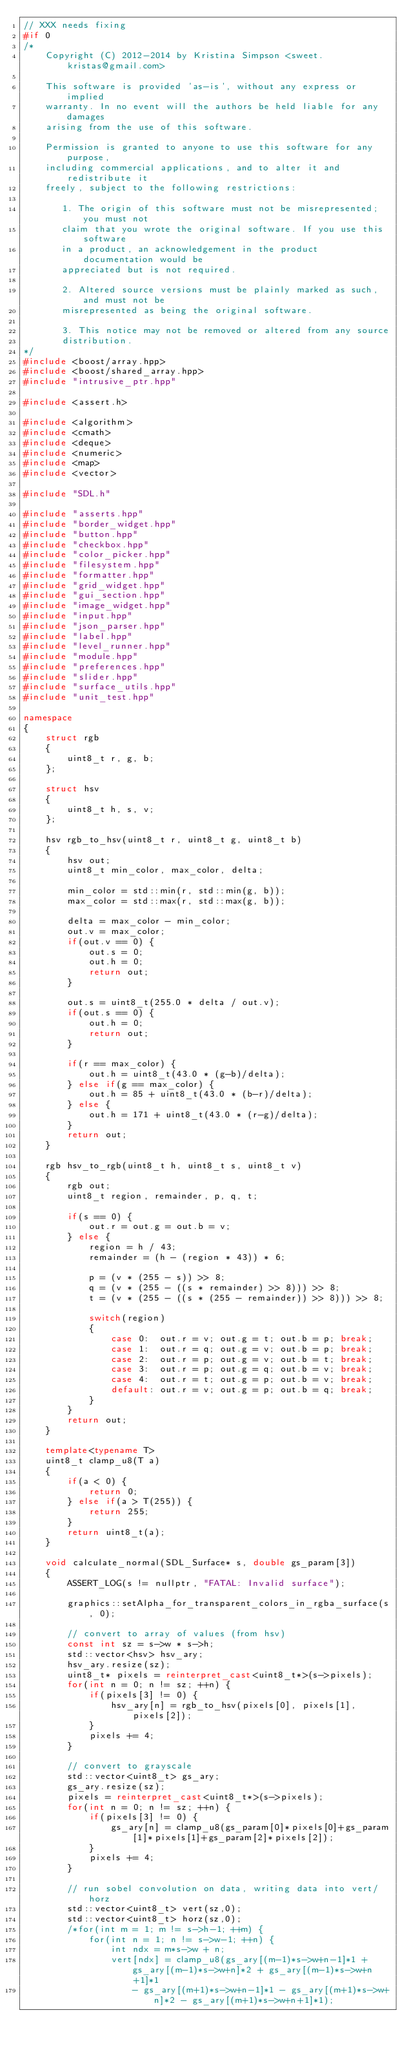Convert code to text. <code><loc_0><loc_0><loc_500><loc_500><_C++_>// XXX needs fixing
#if 0
/*
	Copyright (C) 2012-2014 by Kristina Simpson <sweet.kristas@gmail.com>
	
	This software is provided 'as-is', without any express or implied
	warranty. In no event will the authors be held liable for any damages
	arising from the use of this software.

	Permission is granted to anyone to use this software for any purpose,
	including commercial applications, and to alter it and redistribute it
	freely, subject to the following restrictions:

	   1. The origin of this software must not be misrepresented; you must not
	   claim that you wrote the original software. If you use this software
	   in a product, an acknowledgement in the product documentation would be
	   appreciated but is not required.

	   2. Altered source versions must be plainly marked as such, and must not be
	   misrepresented as being the original software.

	   3. This notice may not be removed or altered from any source
	   distribution.
*/
#include <boost/array.hpp>
#include <boost/shared_array.hpp>
#include "intrusive_ptr.hpp"

#include <assert.h>

#include <algorithm>
#include <cmath>
#include <deque>
#include <numeric>
#include <map>
#include <vector>

#include "SDL.h"

#include "asserts.hpp"
#include "border_widget.hpp"
#include "button.hpp"
#include "checkbox.hpp"
#include "color_picker.hpp"
#include "filesystem.hpp"
#include "formatter.hpp"
#include "grid_widget.hpp"
#include "gui_section.hpp"
#include "image_widget.hpp"
#include "input.hpp"
#include "json_parser.hpp"
#include "label.hpp"
#include "level_runner.hpp"
#include "module.hpp"
#include "preferences.hpp"
#include "slider.hpp"
#include "surface_utils.hpp"
#include "unit_test.hpp"

namespace
{
	struct rgb
	{
		uint8_t r, g, b;
	};

	struct hsv
	{
		uint8_t h, s, v;
	};

	hsv rgb_to_hsv(uint8_t r, uint8_t g, uint8_t b)
	{
		hsv out;
		uint8_t min_color, max_color, delta;

		min_color = std::min(r, std::min(g, b));
		max_color = std::max(r, std::max(g, b));

		delta = max_color - min_color;
		out.v = max_color;
		if(out.v == 0) {
			out.s = 0;
			out.h = 0;
			return out;
		}

		out.s = uint8_t(255.0 * delta / out.v);
		if(out.s == 0) {
			out.h = 0;
			return out;
		}

		if(r == max_color) {
			out.h = uint8_t(43.0 * (g-b)/delta);
		} else if(g == max_color) {
			out.h = 85 + uint8_t(43.0 * (b-r)/delta);
		} else {
			out.h = 171 + uint8_t(43.0 * (r-g)/delta);
		}
		return out;
	}

	rgb hsv_to_rgb(uint8_t h, uint8_t s, uint8_t v)
	{
		rgb out;
		uint8_t region, remainder, p, q, t;

		if(s == 0) {
			out.r = out.g = out.b = v;
		} else {
			region = h / 43;
			remainder = (h - (region * 43)) * 6; 

			p = (v * (255 - s)) >> 8;
			q = (v * (255 - ((s * remainder) >> 8))) >> 8;
			t = (v * (255 - ((s * (255 - remainder)) >> 8))) >> 8;

			switch(region)
			{
				case 0:  out.r = v; out.g = t; out.b = p; break;
				case 1:  out.r = q; out.g = v; out.b = p; break;
				case 2:  out.r = p; out.g = v; out.b = t; break;
				case 3:  out.r = p; out.g = q; out.b = v; break;
				case 4:  out.r = t; out.g = p; out.b = v; break;
				default: out.r = v; out.g = p; out.b = q; break;
			}
		}
		return out;
	}

	template<typename T>
	uint8_t clamp_u8(T a)
	{
		if(a < 0) {
			return 0;
		} else if(a > T(255)) {
			return 255;
		}
		return uint8_t(a);
	}

	void calculate_normal(SDL_Surface* s, double gs_param[3])
	{
		ASSERT_LOG(s != nullptr, "FATAL: Invalid surface");

		graphics::setAlpha_for_transparent_colors_in_rgba_surface(s, 0);

		// convert to array of values (from hsv)
		const int sz = s->w * s->h;
		std::vector<hsv> hsv_ary;
		hsv_ary.resize(sz);
		uint8_t* pixels = reinterpret_cast<uint8_t*>(s->pixels);
		for(int n = 0; n != sz; ++n) {
			if(pixels[3] != 0) {
				hsv_ary[n] = rgb_to_hsv(pixels[0], pixels[1], pixels[2]);
			}
			pixels += 4;
		}

		// convert to grayscale
		std::vector<uint8_t> gs_ary;
		gs_ary.resize(sz);
		pixels = reinterpret_cast<uint8_t*>(s->pixels);
		for(int n = 0; n != sz; ++n) {
			if(pixels[3] != 0) {
				gs_ary[n] = clamp_u8(gs_param[0]*pixels[0]+gs_param[1]*pixels[1]+gs_param[2]*pixels[2]);
			}
			pixels += 4;
		}

		// run sobel convolution on data, writing data into vert/horz
		std::vector<uint8_t> vert(sz,0);
		std::vector<uint8_t> horz(sz,0);
		/*for(int m = 1; m != s->h-1; ++m) {
			for(int n = 1; n != s->w-1; ++n) {
				int ndx = m*s->w + n;
				vert[ndx] = clamp_u8(gs_ary[(m-1)*s->w+n-1]*1 + gs_ary[(m-1)*s->w+n]*2 + gs_ary[(m-1)*s->w+n+1]*1 
					- gs_ary[(m+1)*s->w+n-1]*1 - gs_ary[(m+1)*s->w+n]*2 - gs_ary[(m+1)*s->w+n+1]*1);</code> 